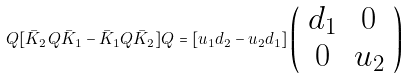Convert formula to latex. <formula><loc_0><loc_0><loc_500><loc_500>Q [ \bar { K } _ { 2 } Q \bar { K } _ { 1 } - \bar { K } _ { 1 } Q \bar { K } _ { 2 } ] Q = [ u _ { 1 } d _ { 2 } - u _ { 2 } d _ { 1 } ] \left ( \begin{array} { c c } { { d _ { 1 } } } & { 0 } \\ { 0 } & { { u _ { 2 } } } \end{array} \right )</formula> 